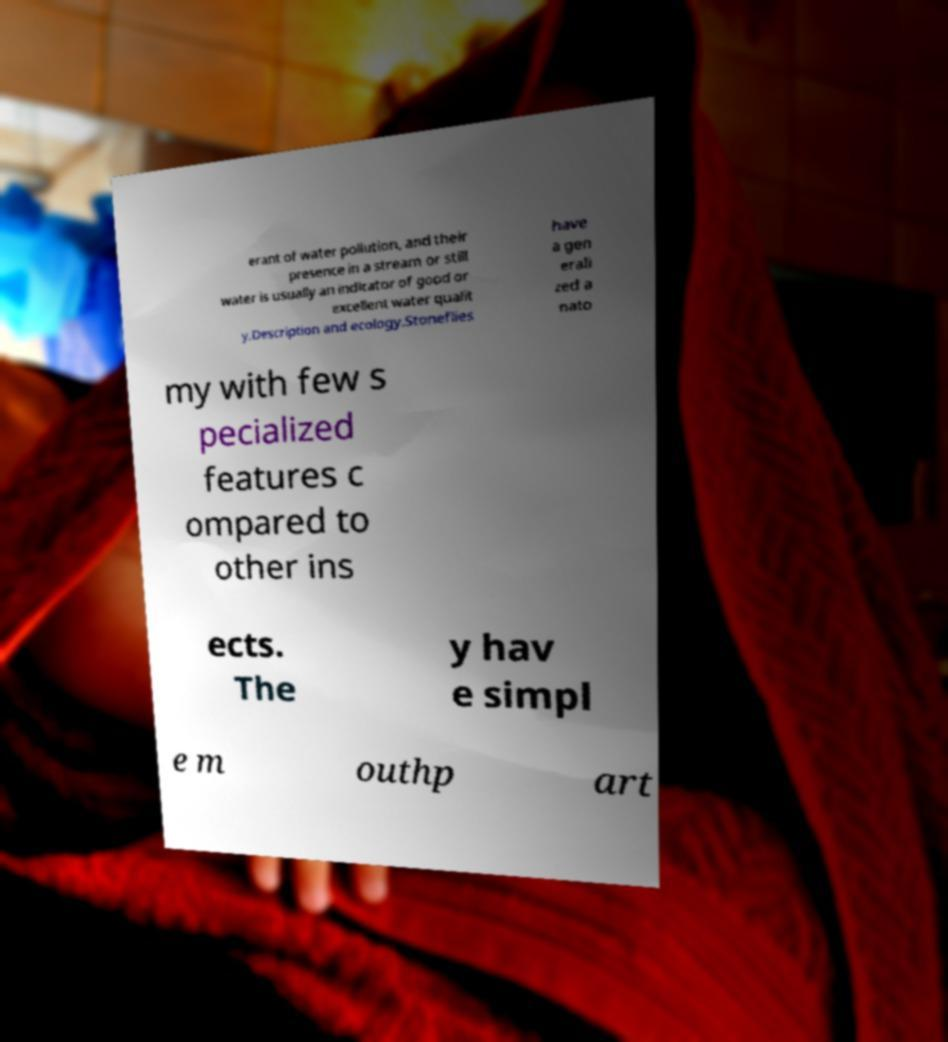There's text embedded in this image that I need extracted. Can you transcribe it verbatim? erant of water pollution, and their presence in a stream or still water is usually an indicator of good or excellent water qualit y.Description and ecology.Stoneflies have a gen erali zed a nato my with few s pecialized features c ompared to other ins ects. The y hav e simpl e m outhp art 